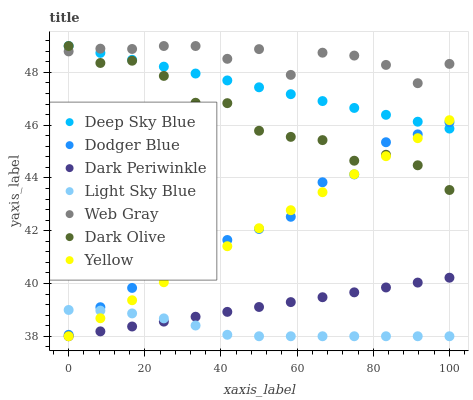Does Light Sky Blue have the minimum area under the curve?
Answer yes or no. Yes. Does Web Gray have the maximum area under the curve?
Answer yes or no. Yes. Does Dark Olive have the minimum area under the curve?
Answer yes or no. No. Does Dark Olive have the maximum area under the curve?
Answer yes or no. No. Is Dark Periwinkle the smoothest?
Answer yes or no. Yes. Is Web Gray the roughest?
Answer yes or no. Yes. Is Dark Olive the smoothest?
Answer yes or no. No. Is Dark Olive the roughest?
Answer yes or no. No. Does Yellow have the lowest value?
Answer yes or no. Yes. Does Dark Olive have the lowest value?
Answer yes or no. No. Does Deep Sky Blue have the highest value?
Answer yes or no. Yes. Does Yellow have the highest value?
Answer yes or no. No. Is Dodger Blue less than Web Gray?
Answer yes or no. Yes. Is Dodger Blue greater than Dark Periwinkle?
Answer yes or no. Yes. Does Yellow intersect Dark Periwinkle?
Answer yes or no. Yes. Is Yellow less than Dark Periwinkle?
Answer yes or no. No. Is Yellow greater than Dark Periwinkle?
Answer yes or no. No. Does Dodger Blue intersect Web Gray?
Answer yes or no. No. 